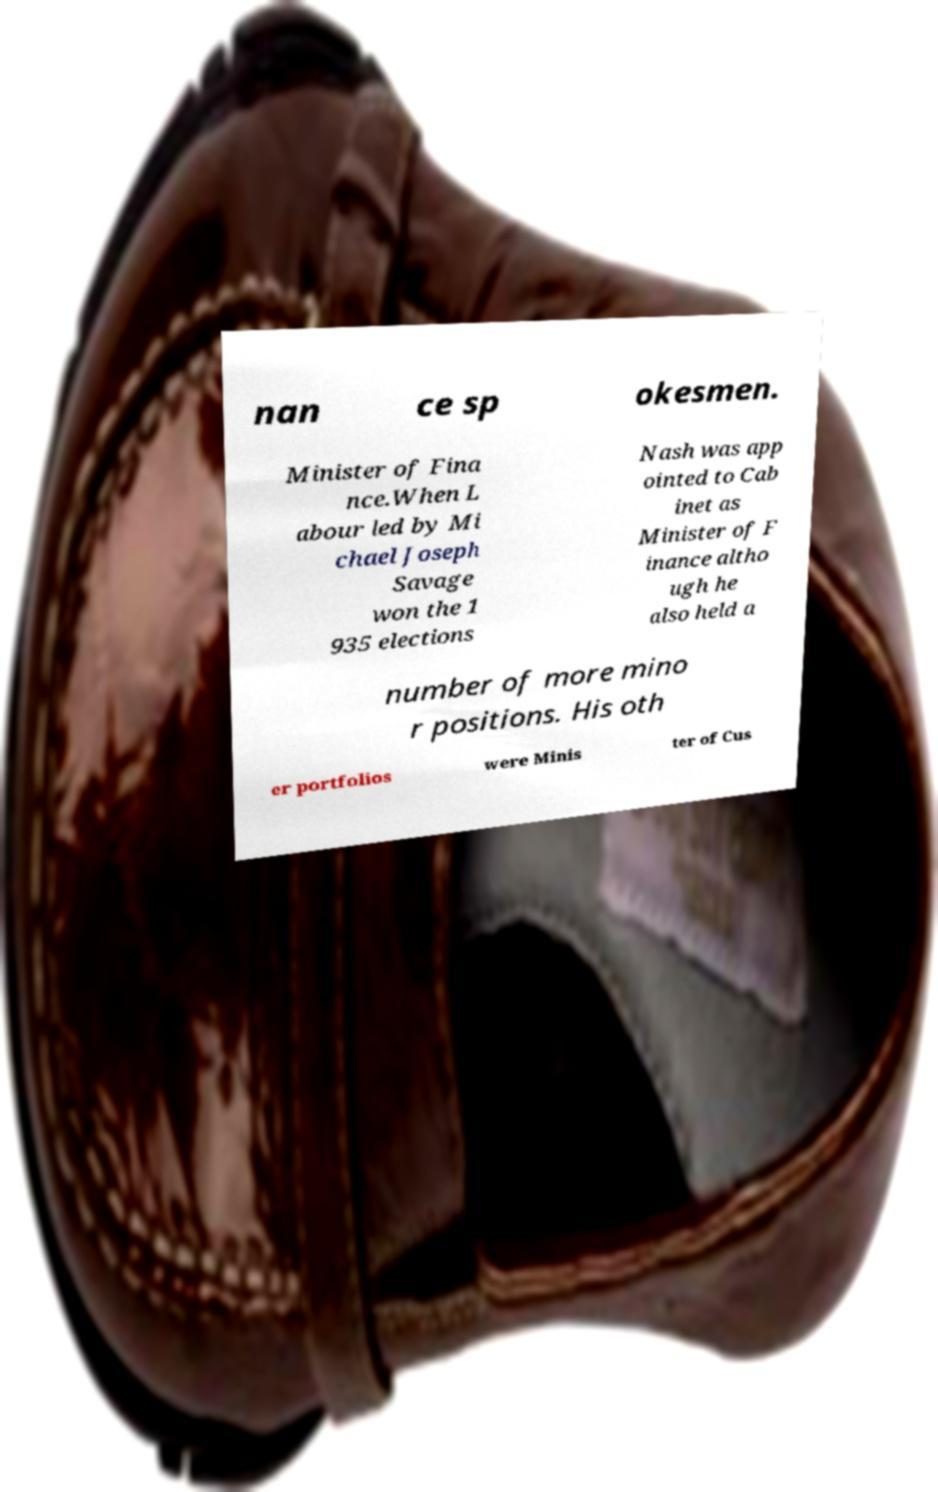Please identify and transcribe the text found in this image. nan ce sp okesmen. Minister of Fina nce.When L abour led by Mi chael Joseph Savage won the 1 935 elections Nash was app ointed to Cab inet as Minister of F inance altho ugh he also held a number of more mino r positions. His oth er portfolios were Minis ter of Cus 